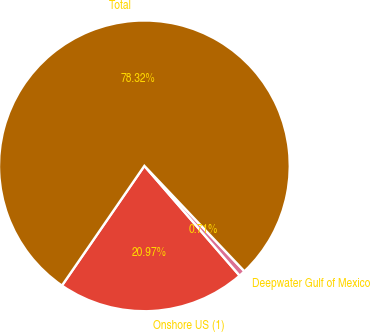Convert chart. <chart><loc_0><loc_0><loc_500><loc_500><pie_chart><fcel>Onshore US (1)<fcel>Deepwater Gulf of Mexico<fcel>Total<nl><fcel>20.97%<fcel>0.71%<fcel>78.32%<nl></chart> 